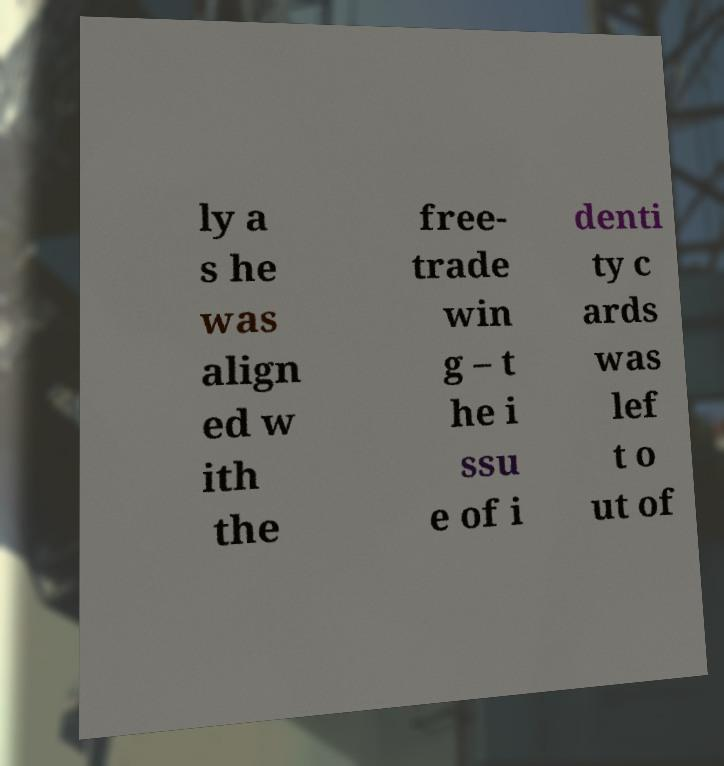For documentation purposes, I need the text within this image transcribed. Could you provide that? ly a s he was align ed w ith the free- trade win g – t he i ssu e of i denti ty c ards was lef t o ut of 